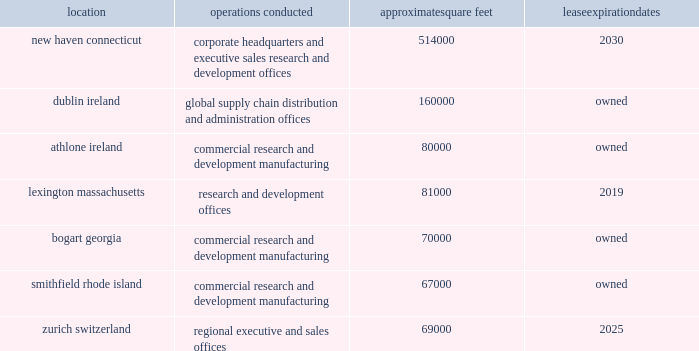Risks related to our common stock our stock price is extremely volatile .
The trading price of our common stock has been extremely volatile and may continue to be volatile in the future .
Many factors could have an impact on our stock price , including fluctuations in our or our competitors 2019 operating results , clinical trial results or adverse events associated with our products , product development by us or our competitors , changes in laws , including healthcare , tax or intellectual property laws , intellectual property developments , changes in reimbursement or drug pricing , the existence or outcome of litigation or government proceedings , including the sec/doj investigation , failure to resolve , delays in resolving or other developments with respect to the issues raised in the warning letter , acquisitions or other strategic transactions , and the perceptions of our investors that we are not performing or meeting expectations .
The trading price of the common stock of many biopharmaceutical companies , including ours , has experienced extreme price and volume fluctuations , which have at times been unrelated to the operating performance of the companies whose stocks were affected .
Anti-takeover provisions in our charter and bylaws and under delaware law could make a third-party acquisition of us difficult and may frustrate any attempt to remove or replace our current management .
Our corporate charter and by-law provisions may discourage certain types of transactions involving an actual or potential change of control that might be beneficial to us or our stockholders .
Our bylaws provide that special meetings of our stockholders may be called only by the chairman of the board , the president , the secretary , or a majority of the board of directors , or upon the written request of stockholders who together own of record 25% ( 25 % ) of the outstanding stock of all classes entitled to vote at such meeting .
Our bylaws also specify that the authorized number of directors may be changed only by resolution of the board of directors .
Our charter does not include a provision for cumulative voting for directors , which may have enabled a minority stockholder holding a sufficient percentage of a class of shares to elect one or more directors .
Under our charter , our board of directors has the authority , without further action by stockholders , to designate up to 5 shares of preferred stock in one or more series .
The rights of the holders of common stock will be subject to , and may be adversely affected by , the rights of the holders of any class or series of preferred stock that may be issued in the future .
Because we are a delaware corporation , the anti-takeover provisions of delaware law could make it more difficult for a third party to acquire control of us , even if the change in control would be beneficial to stockholders .
We are subject to the provisions of section 203 of the delaware general laws , which prohibits a person who owns in excess of 15% ( 15 % ) of our outstanding voting stock from merging or combining with us for a period of three years after the date of the transaction in which the person acquired in excess of 15% ( 15 % ) of our outstanding voting stock , unless the merger or combination is approved in a prescribed manner .
Item 1b .
Unresolved staff comments .
Item 2 .
Properties .
We conduct our primary operations at the owned and leased facilities described below .
Location operations conducted approximate square feet expiration new haven , connecticut corporate headquarters and executive , sales , research and development offices 514000 2030 dublin , ireland global supply chain , distribution , and administration offices 160000 owned .
We believe that our administrative office space is adequate to meet our needs for the foreseeable future .
We also believe that our research and development facilities and our manufacturing facilities , together with third party manufacturing facilities , will be adequate for our on-going activities .
In addition to the locations above , we also lease space in other u.s .
Locations and in foreign countries to support our operations as a global organization. .
How many square feet are owned by the company? 
Computations: (((160000 + 80000) + 70000) + 67000)
Answer: 377000.0. 